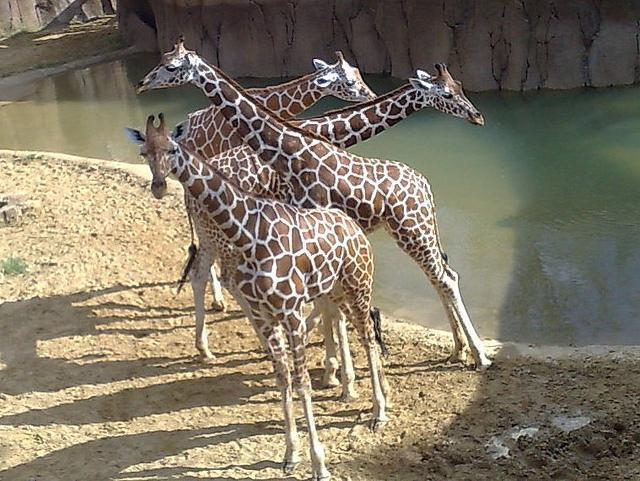How many animals?
Give a very brief answer. 4. How many giraffes are in the picture?
Give a very brief answer. 4. How many shelves does the refrigerator have?
Give a very brief answer. 0. 